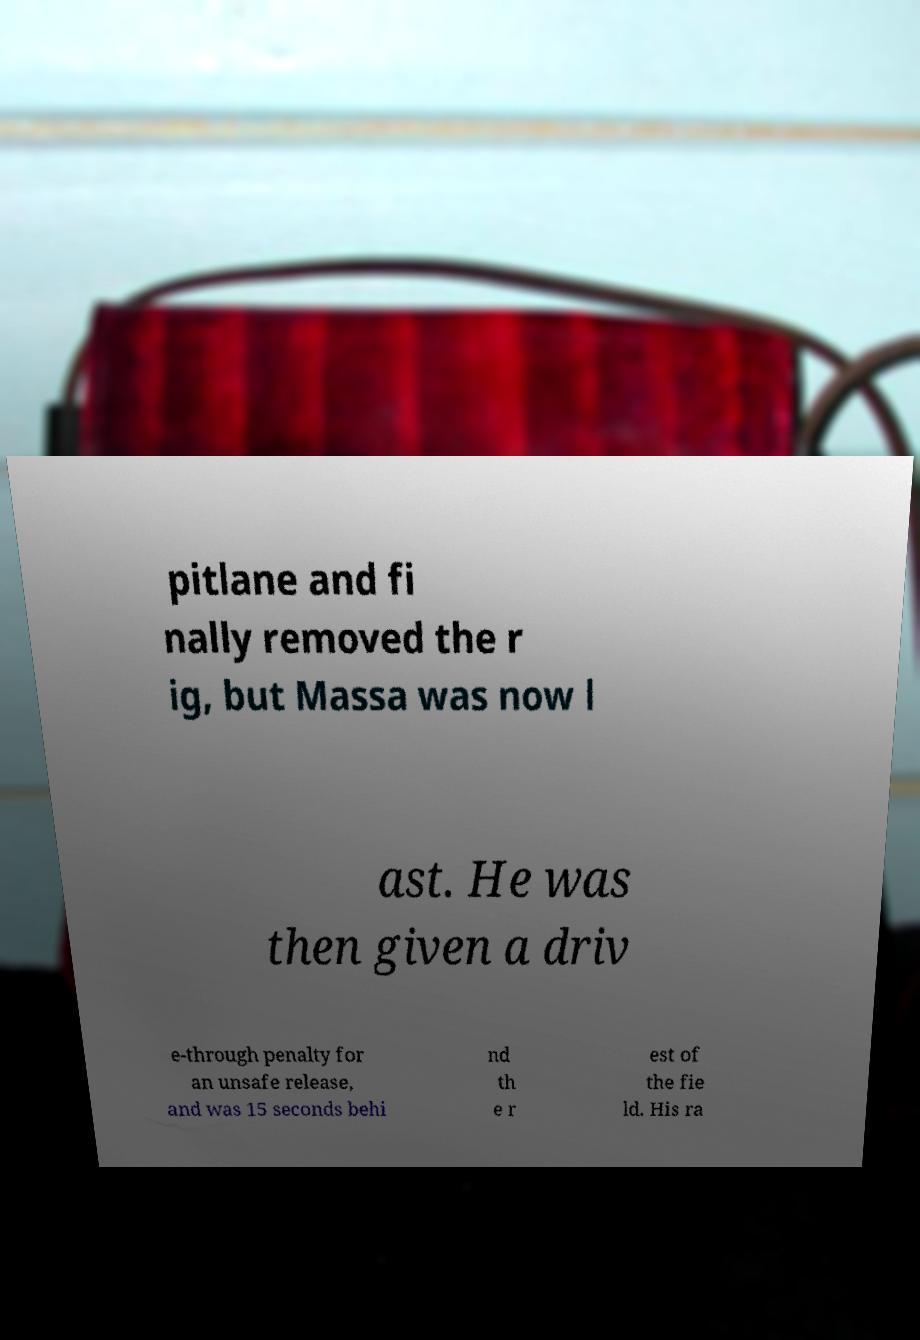Can you accurately transcribe the text from the provided image for me? pitlane and fi nally removed the r ig, but Massa was now l ast. He was then given a driv e-through penalty for an unsafe release, and was 15 seconds behi nd th e r est of the fie ld. His ra 